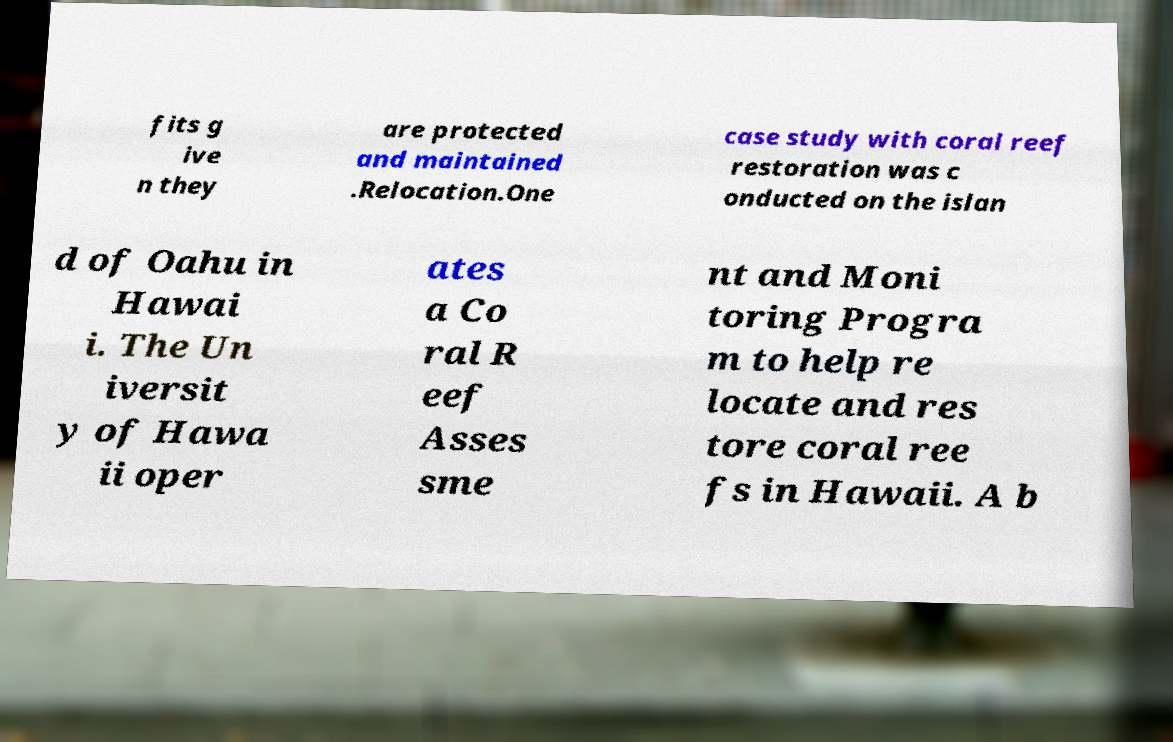For documentation purposes, I need the text within this image transcribed. Could you provide that? fits g ive n they are protected and maintained .Relocation.One case study with coral reef restoration was c onducted on the islan d of Oahu in Hawai i. The Un iversit y of Hawa ii oper ates a Co ral R eef Asses sme nt and Moni toring Progra m to help re locate and res tore coral ree fs in Hawaii. A b 